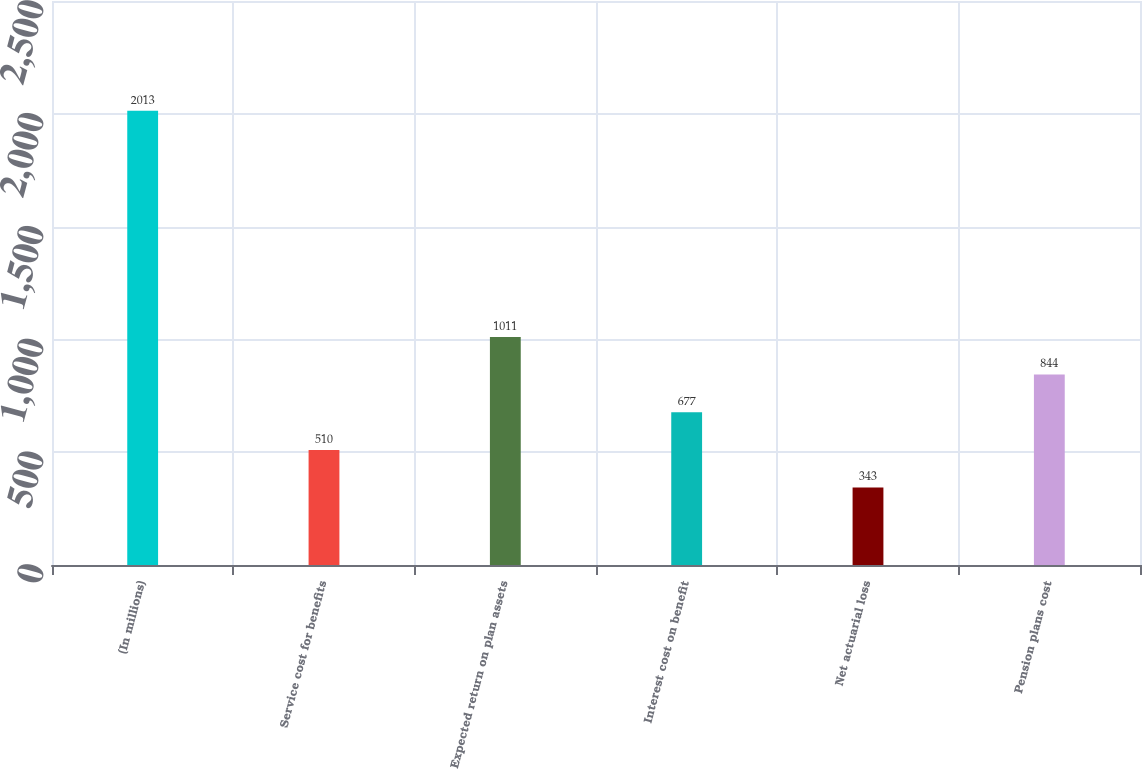Convert chart to OTSL. <chart><loc_0><loc_0><loc_500><loc_500><bar_chart><fcel>(In millions)<fcel>Service cost for benefits<fcel>Expected return on plan assets<fcel>Interest cost on benefit<fcel>Net actuarial loss<fcel>Pension plans cost<nl><fcel>2013<fcel>510<fcel>1011<fcel>677<fcel>343<fcel>844<nl></chart> 